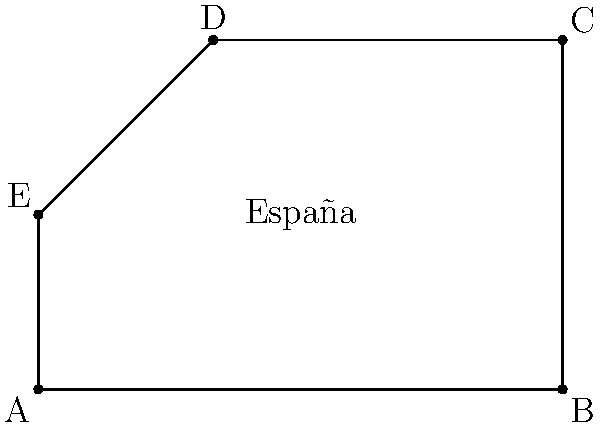Imagina que estás ayudando a crear un mapa digital de España para un proyecto de cooperación internacional. Se te dan las coordenadas de cinco puntos que representan las fronteras simplificadas del país en kilómetros: A(0,0), B(6,0), C(6,4), D(2,4), y E(0,2). ¿Cuál es el área aproximada de España en kilómetros cuadrados según estas coordenadas? Para calcular el área de España usando las coordenadas dadas, podemos dividir la forma en dos triángulos y un rectángulo:

1. Triángulo AEB:
   Base = 6 km, Altura = 2 km
   Área = $\frac{1}{2} \times 6 \times 2 = 6$ km²

2. Rectángulo BCDE:
   Largo = 6 km, Ancho = 2 km
   Área = $6 \times 2 = 12$ km²

3. Triángulo CDE:
   Base = 4 km, Altura = 2 km
   Área = $\frac{1}{2} \times 4 \times 2 = 4$ km²

Área total = Área del triángulo AEB + Área del rectángulo BCDE + Área del triángulo CDE
           = $6 + 12 + 4 = 22$ km²

Por lo tanto, el área aproximada de España según estas coordenadas simplificadas es de 22 kilómetros cuadrados.
Answer: 22 km² 